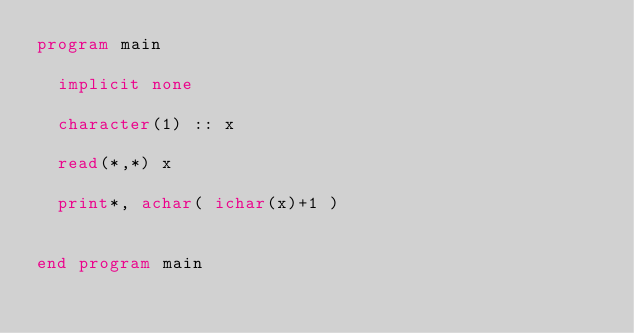<code> <loc_0><loc_0><loc_500><loc_500><_FORTRAN_>program main

  implicit none
  
  character(1) :: x 

  read(*,*) x

  print*, achar( ichar(x)+1 )


end program main
</code> 